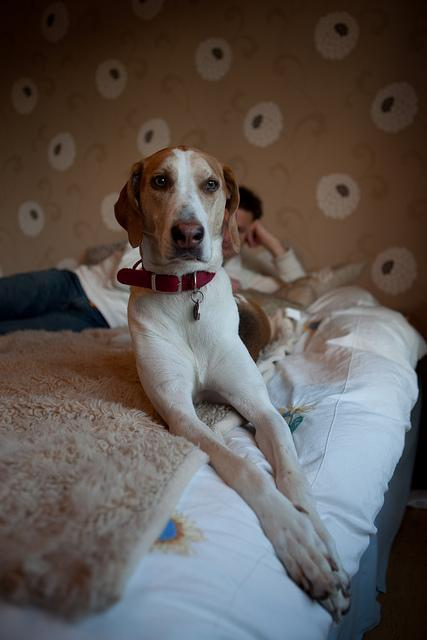What is the purpose of the item tied around his neck? identification 